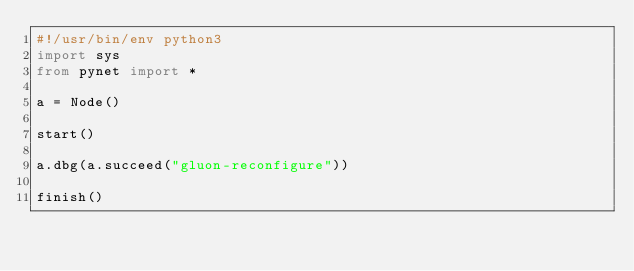<code> <loc_0><loc_0><loc_500><loc_500><_Python_>#!/usr/bin/env python3
import sys
from pynet import *

a = Node()

start()

a.dbg(a.succeed("gluon-reconfigure"))

finish()
</code> 